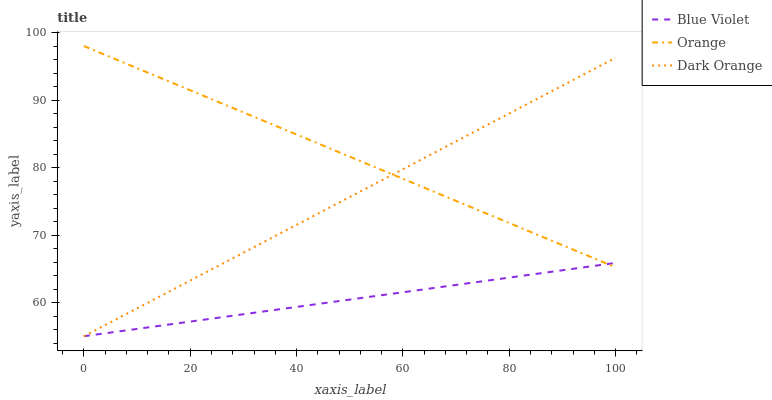Does Dark Orange have the minimum area under the curve?
Answer yes or no. No. Does Dark Orange have the maximum area under the curve?
Answer yes or no. No. Is Blue Violet the smoothest?
Answer yes or no. No. Is Blue Violet the roughest?
Answer yes or no. No. Does Dark Orange have the highest value?
Answer yes or no. No. 